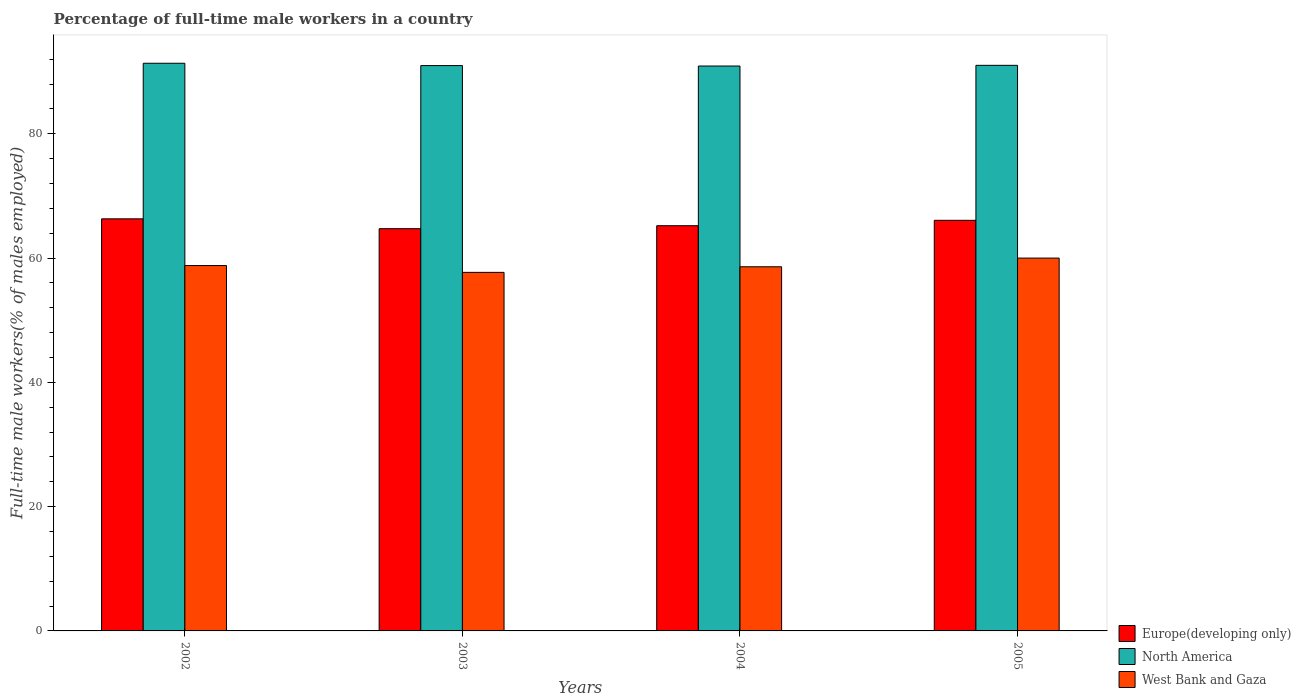How many different coloured bars are there?
Make the answer very short. 3. How many bars are there on the 1st tick from the left?
Make the answer very short. 3. How many bars are there on the 1st tick from the right?
Provide a short and direct response. 3. What is the percentage of full-time male workers in Europe(developing only) in 2005?
Provide a short and direct response. 66.08. Across all years, what is the maximum percentage of full-time male workers in West Bank and Gaza?
Your answer should be very brief. 60. Across all years, what is the minimum percentage of full-time male workers in West Bank and Gaza?
Offer a terse response. 57.7. What is the total percentage of full-time male workers in North America in the graph?
Offer a terse response. 364.26. What is the difference between the percentage of full-time male workers in North America in 2002 and that in 2004?
Ensure brevity in your answer.  0.44. What is the difference between the percentage of full-time male workers in North America in 2002 and the percentage of full-time male workers in Europe(developing only) in 2004?
Offer a terse response. 26.14. What is the average percentage of full-time male workers in Europe(developing only) per year?
Give a very brief answer. 65.58. In the year 2004, what is the difference between the percentage of full-time male workers in West Bank and Gaza and percentage of full-time male workers in Europe(developing only)?
Offer a very short reply. -6.61. What is the ratio of the percentage of full-time male workers in West Bank and Gaza in 2002 to that in 2004?
Ensure brevity in your answer.  1. Is the percentage of full-time male workers in West Bank and Gaza in 2004 less than that in 2005?
Ensure brevity in your answer.  Yes. What is the difference between the highest and the second highest percentage of full-time male workers in Europe(developing only)?
Provide a succinct answer. 0.24. What is the difference between the highest and the lowest percentage of full-time male workers in North America?
Offer a very short reply. 0.44. Is the sum of the percentage of full-time male workers in Europe(developing only) in 2003 and 2004 greater than the maximum percentage of full-time male workers in West Bank and Gaza across all years?
Keep it short and to the point. Yes. What does the 2nd bar from the left in 2005 represents?
Keep it short and to the point. North America. What does the 3rd bar from the right in 2003 represents?
Keep it short and to the point. Europe(developing only). Is it the case that in every year, the sum of the percentage of full-time male workers in North America and percentage of full-time male workers in Europe(developing only) is greater than the percentage of full-time male workers in West Bank and Gaza?
Your response must be concise. Yes. Are the values on the major ticks of Y-axis written in scientific E-notation?
Make the answer very short. No. Does the graph contain any zero values?
Ensure brevity in your answer.  No. Where does the legend appear in the graph?
Your answer should be compact. Bottom right. How many legend labels are there?
Ensure brevity in your answer.  3. What is the title of the graph?
Offer a very short reply. Percentage of full-time male workers in a country. What is the label or title of the X-axis?
Your answer should be compact. Years. What is the label or title of the Y-axis?
Offer a very short reply. Full-time male workers(% of males employed). What is the Full-time male workers(% of males employed) of Europe(developing only) in 2002?
Your answer should be very brief. 66.31. What is the Full-time male workers(% of males employed) in North America in 2002?
Your response must be concise. 91.35. What is the Full-time male workers(% of males employed) of West Bank and Gaza in 2002?
Give a very brief answer. 58.8. What is the Full-time male workers(% of males employed) of Europe(developing only) in 2003?
Your answer should be very brief. 64.73. What is the Full-time male workers(% of males employed) in North America in 2003?
Your response must be concise. 90.98. What is the Full-time male workers(% of males employed) of West Bank and Gaza in 2003?
Ensure brevity in your answer.  57.7. What is the Full-time male workers(% of males employed) of Europe(developing only) in 2004?
Your response must be concise. 65.21. What is the Full-time male workers(% of males employed) in North America in 2004?
Your answer should be very brief. 90.91. What is the Full-time male workers(% of males employed) in West Bank and Gaza in 2004?
Your response must be concise. 58.6. What is the Full-time male workers(% of males employed) in Europe(developing only) in 2005?
Make the answer very short. 66.08. What is the Full-time male workers(% of males employed) of North America in 2005?
Ensure brevity in your answer.  91.02. Across all years, what is the maximum Full-time male workers(% of males employed) in Europe(developing only)?
Ensure brevity in your answer.  66.31. Across all years, what is the maximum Full-time male workers(% of males employed) of North America?
Your response must be concise. 91.35. Across all years, what is the maximum Full-time male workers(% of males employed) in West Bank and Gaza?
Make the answer very short. 60. Across all years, what is the minimum Full-time male workers(% of males employed) in Europe(developing only)?
Your answer should be very brief. 64.73. Across all years, what is the minimum Full-time male workers(% of males employed) in North America?
Keep it short and to the point. 90.91. Across all years, what is the minimum Full-time male workers(% of males employed) of West Bank and Gaza?
Provide a succinct answer. 57.7. What is the total Full-time male workers(% of males employed) of Europe(developing only) in the graph?
Your answer should be very brief. 262.33. What is the total Full-time male workers(% of males employed) of North America in the graph?
Your answer should be very brief. 364.26. What is the total Full-time male workers(% of males employed) of West Bank and Gaza in the graph?
Ensure brevity in your answer.  235.1. What is the difference between the Full-time male workers(% of males employed) of Europe(developing only) in 2002 and that in 2003?
Offer a terse response. 1.59. What is the difference between the Full-time male workers(% of males employed) in North America in 2002 and that in 2003?
Make the answer very short. 0.37. What is the difference between the Full-time male workers(% of males employed) of Europe(developing only) in 2002 and that in 2004?
Your response must be concise. 1.11. What is the difference between the Full-time male workers(% of males employed) of North America in 2002 and that in 2004?
Your answer should be very brief. 0.44. What is the difference between the Full-time male workers(% of males employed) in West Bank and Gaza in 2002 and that in 2004?
Give a very brief answer. 0.2. What is the difference between the Full-time male workers(% of males employed) in Europe(developing only) in 2002 and that in 2005?
Your response must be concise. 0.24. What is the difference between the Full-time male workers(% of males employed) in North America in 2002 and that in 2005?
Offer a very short reply. 0.33. What is the difference between the Full-time male workers(% of males employed) of West Bank and Gaza in 2002 and that in 2005?
Your answer should be compact. -1.2. What is the difference between the Full-time male workers(% of males employed) of Europe(developing only) in 2003 and that in 2004?
Your response must be concise. -0.48. What is the difference between the Full-time male workers(% of males employed) in North America in 2003 and that in 2004?
Your answer should be very brief. 0.07. What is the difference between the Full-time male workers(% of males employed) of West Bank and Gaza in 2003 and that in 2004?
Your response must be concise. -0.9. What is the difference between the Full-time male workers(% of males employed) of Europe(developing only) in 2003 and that in 2005?
Provide a short and direct response. -1.35. What is the difference between the Full-time male workers(% of males employed) in North America in 2003 and that in 2005?
Your answer should be very brief. -0.04. What is the difference between the Full-time male workers(% of males employed) in West Bank and Gaza in 2003 and that in 2005?
Your answer should be compact. -2.3. What is the difference between the Full-time male workers(% of males employed) in Europe(developing only) in 2004 and that in 2005?
Provide a succinct answer. -0.87. What is the difference between the Full-time male workers(% of males employed) in North America in 2004 and that in 2005?
Provide a succinct answer. -0.11. What is the difference between the Full-time male workers(% of males employed) in West Bank and Gaza in 2004 and that in 2005?
Provide a short and direct response. -1.4. What is the difference between the Full-time male workers(% of males employed) of Europe(developing only) in 2002 and the Full-time male workers(% of males employed) of North America in 2003?
Offer a very short reply. -24.66. What is the difference between the Full-time male workers(% of males employed) of Europe(developing only) in 2002 and the Full-time male workers(% of males employed) of West Bank and Gaza in 2003?
Your answer should be compact. 8.61. What is the difference between the Full-time male workers(% of males employed) of North America in 2002 and the Full-time male workers(% of males employed) of West Bank and Gaza in 2003?
Your answer should be very brief. 33.65. What is the difference between the Full-time male workers(% of males employed) in Europe(developing only) in 2002 and the Full-time male workers(% of males employed) in North America in 2004?
Keep it short and to the point. -24.59. What is the difference between the Full-time male workers(% of males employed) in Europe(developing only) in 2002 and the Full-time male workers(% of males employed) in West Bank and Gaza in 2004?
Offer a very short reply. 7.71. What is the difference between the Full-time male workers(% of males employed) in North America in 2002 and the Full-time male workers(% of males employed) in West Bank and Gaza in 2004?
Your answer should be compact. 32.75. What is the difference between the Full-time male workers(% of males employed) of Europe(developing only) in 2002 and the Full-time male workers(% of males employed) of North America in 2005?
Ensure brevity in your answer.  -24.7. What is the difference between the Full-time male workers(% of males employed) in Europe(developing only) in 2002 and the Full-time male workers(% of males employed) in West Bank and Gaza in 2005?
Make the answer very short. 6.31. What is the difference between the Full-time male workers(% of males employed) of North America in 2002 and the Full-time male workers(% of males employed) of West Bank and Gaza in 2005?
Keep it short and to the point. 31.35. What is the difference between the Full-time male workers(% of males employed) in Europe(developing only) in 2003 and the Full-time male workers(% of males employed) in North America in 2004?
Make the answer very short. -26.18. What is the difference between the Full-time male workers(% of males employed) of Europe(developing only) in 2003 and the Full-time male workers(% of males employed) of West Bank and Gaza in 2004?
Provide a succinct answer. 6.13. What is the difference between the Full-time male workers(% of males employed) of North America in 2003 and the Full-time male workers(% of males employed) of West Bank and Gaza in 2004?
Provide a succinct answer. 32.38. What is the difference between the Full-time male workers(% of males employed) of Europe(developing only) in 2003 and the Full-time male workers(% of males employed) of North America in 2005?
Offer a terse response. -26.29. What is the difference between the Full-time male workers(% of males employed) of Europe(developing only) in 2003 and the Full-time male workers(% of males employed) of West Bank and Gaza in 2005?
Ensure brevity in your answer.  4.73. What is the difference between the Full-time male workers(% of males employed) of North America in 2003 and the Full-time male workers(% of males employed) of West Bank and Gaza in 2005?
Offer a very short reply. 30.98. What is the difference between the Full-time male workers(% of males employed) in Europe(developing only) in 2004 and the Full-time male workers(% of males employed) in North America in 2005?
Your response must be concise. -25.81. What is the difference between the Full-time male workers(% of males employed) of Europe(developing only) in 2004 and the Full-time male workers(% of males employed) of West Bank and Gaza in 2005?
Your answer should be very brief. 5.21. What is the difference between the Full-time male workers(% of males employed) in North America in 2004 and the Full-time male workers(% of males employed) in West Bank and Gaza in 2005?
Your answer should be very brief. 30.91. What is the average Full-time male workers(% of males employed) in Europe(developing only) per year?
Offer a terse response. 65.58. What is the average Full-time male workers(% of males employed) in North America per year?
Offer a terse response. 91.06. What is the average Full-time male workers(% of males employed) of West Bank and Gaza per year?
Offer a very short reply. 58.77. In the year 2002, what is the difference between the Full-time male workers(% of males employed) in Europe(developing only) and Full-time male workers(% of males employed) in North America?
Offer a very short reply. -25.04. In the year 2002, what is the difference between the Full-time male workers(% of males employed) of Europe(developing only) and Full-time male workers(% of males employed) of West Bank and Gaza?
Your answer should be compact. 7.51. In the year 2002, what is the difference between the Full-time male workers(% of males employed) in North America and Full-time male workers(% of males employed) in West Bank and Gaza?
Your answer should be very brief. 32.55. In the year 2003, what is the difference between the Full-time male workers(% of males employed) of Europe(developing only) and Full-time male workers(% of males employed) of North America?
Make the answer very short. -26.25. In the year 2003, what is the difference between the Full-time male workers(% of males employed) of Europe(developing only) and Full-time male workers(% of males employed) of West Bank and Gaza?
Ensure brevity in your answer.  7.03. In the year 2003, what is the difference between the Full-time male workers(% of males employed) of North America and Full-time male workers(% of males employed) of West Bank and Gaza?
Give a very brief answer. 33.28. In the year 2004, what is the difference between the Full-time male workers(% of males employed) of Europe(developing only) and Full-time male workers(% of males employed) of North America?
Keep it short and to the point. -25.7. In the year 2004, what is the difference between the Full-time male workers(% of males employed) of Europe(developing only) and Full-time male workers(% of males employed) of West Bank and Gaza?
Give a very brief answer. 6.61. In the year 2004, what is the difference between the Full-time male workers(% of males employed) in North America and Full-time male workers(% of males employed) in West Bank and Gaza?
Provide a succinct answer. 32.31. In the year 2005, what is the difference between the Full-time male workers(% of males employed) in Europe(developing only) and Full-time male workers(% of males employed) in North America?
Offer a very short reply. -24.94. In the year 2005, what is the difference between the Full-time male workers(% of males employed) of Europe(developing only) and Full-time male workers(% of males employed) of West Bank and Gaza?
Ensure brevity in your answer.  6.08. In the year 2005, what is the difference between the Full-time male workers(% of males employed) of North America and Full-time male workers(% of males employed) of West Bank and Gaza?
Offer a terse response. 31.02. What is the ratio of the Full-time male workers(% of males employed) in Europe(developing only) in 2002 to that in 2003?
Make the answer very short. 1.02. What is the ratio of the Full-time male workers(% of males employed) of West Bank and Gaza in 2002 to that in 2003?
Offer a very short reply. 1.02. What is the ratio of the Full-time male workers(% of males employed) of Europe(developing only) in 2002 to that in 2005?
Your answer should be compact. 1. What is the ratio of the Full-time male workers(% of males employed) of North America in 2002 to that in 2005?
Offer a terse response. 1. What is the ratio of the Full-time male workers(% of males employed) in Europe(developing only) in 2003 to that in 2004?
Offer a terse response. 0.99. What is the ratio of the Full-time male workers(% of males employed) of North America in 2003 to that in 2004?
Ensure brevity in your answer.  1. What is the ratio of the Full-time male workers(% of males employed) in West Bank and Gaza in 2003 to that in 2004?
Offer a very short reply. 0.98. What is the ratio of the Full-time male workers(% of males employed) of Europe(developing only) in 2003 to that in 2005?
Make the answer very short. 0.98. What is the ratio of the Full-time male workers(% of males employed) of North America in 2003 to that in 2005?
Give a very brief answer. 1. What is the ratio of the Full-time male workers(% of males employed) of West Bank and Gaza in 2003 to that in 2005?
Provide a succinct answer. 0.96. What is the ratio of the Full-time male workers(% of males employed) in Europe(developing only) in 2004 to that in 2005?
Offer a very short reply. 0.99. What is the ratio of the Full-time male workers(% of males employed) of North America in 2004 to that in 2005?
Make the answer very short. 1. What is the ratio of the Full-time male workers(% of males employed) in West Bank and Gaza in 2004 to that in 2005?
Make the answer very short. 0.98. What is the difference between the highest and the second highest Full-time male workers(% of males employed) of Europe(developing only)?
Provide a short and direct response. 0.24. What is the difference between the highest and the second highest Full-time male workers(% of males employed) of North America?
Keep it short and to the point. 0.33. What is the difference between the highest and the lowest Full-time male workers(% of males employed) in Europe(developing only)?
Make the answer very short. 1.59. What is the difference between the highest and the lowest Full-time male workers(% of males employed) in North America?
Your answer should be compact. 0.44. What is the difference between the highest and the lowest Full-time male workers(% of males employed) in West Bank and Gaza?
Make the answer very short. 2.3. 